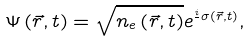<formula> <loc_0><loc_0><loc_500><loc_500>\Psi \left ( { { \vec { r } } , t } \right ) = \sqrt { n _ { e } \left ( { { \vec { r } } , t } \right ) } e ^ { \frac { i } { } \sigma \left ( { \vec { r } } , t \right ) } ,</formula> 